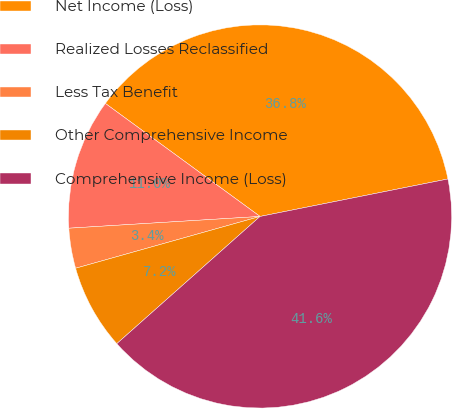Convert chart. <chart><loc_0><loc_0><loc_500><loc_500><pie_chart><fcel>Net Income (Loss)<fcel>Realized Losses Reclassified<fcel>Less Tax Benefit<fcel>Other Comprehensive Income<fcel>Comprehensive Income (Loss)<nl><fcel>36.82%<fcel>11.02%<fcel>3.38%<fcel>7.2%<fcel>41.57%<nl></chart> 